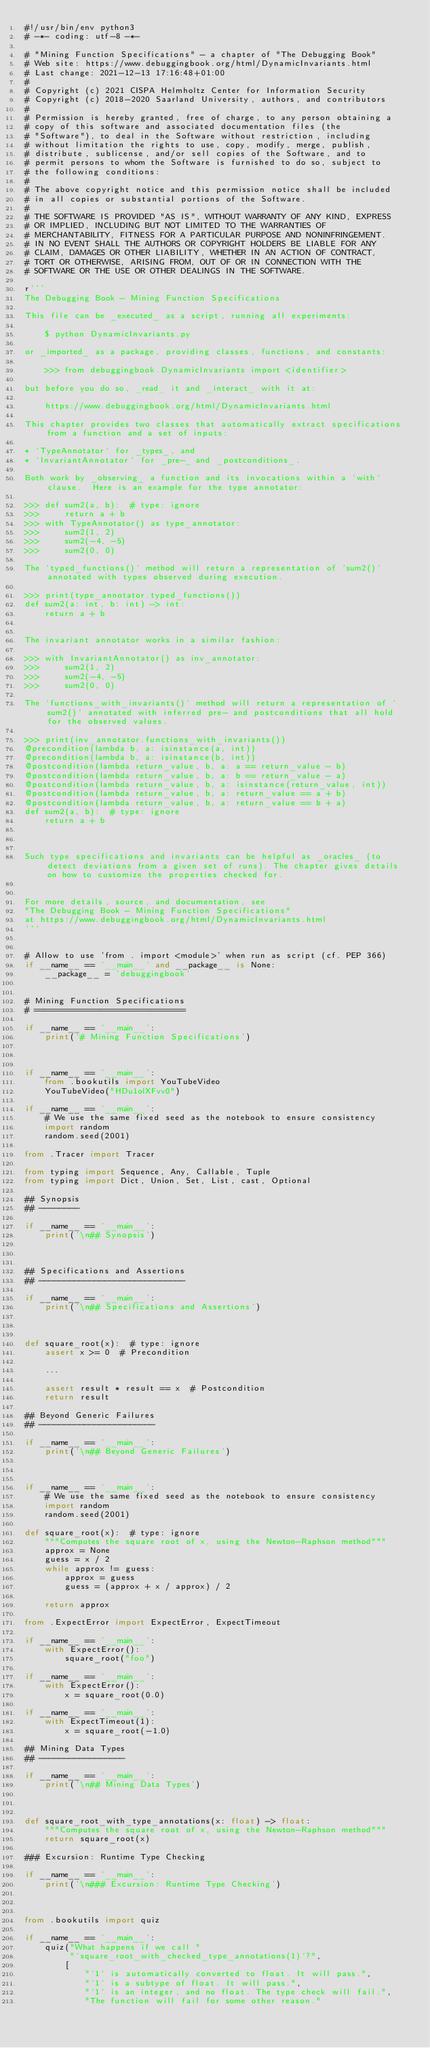Convert code to text. <code><loc_0><loc_0><loc_500><loc_500><_Python_>#!/usr/bin/env python3
# -*- coding: utf-8 -*-

# "Mining Function Specifications" - a chapter of "The Debugging Book"
# Web site: https://www.debuggingbook.org/html/DynamicInvariants.html
# Last change: 2021-12-13 17:16:48+01:00
#
# Copyright (c) 2021 CISPA Helmholtz Center for Information Security
# Copyright (c) 2018-2020 Saarland University, authors, and contributors
#
# Permission is hereby granted, free of charge, to any person obtaining a
# copy of this software and associated documentation files (the
# "Software"), to deal in the Software without restriction, including
# without limitation the rights to use, copy, modify, merge, publish,
# distribute, sublicense, and/or sell copies of the Software, and to
# permit persons to whom the Software is furnished to do so, subject to
# the following conditions:
#
# The above copyright notice and this permission notice shall be included
# in all copies or substantial portions of the Software.
#
# THE SOFTWARE IS PROVIDED "AS IS", WITHOUT WARRANTY OF ANY KIND, EXPRESS
# OR IMPLIED, INCLUDING BUT NOT LIMITED TO THE WARRANTIES OF
# MERCHANTABILITY, FITNESS FOR A PARTICULAR PURPOSE AND NONINFRINGEMENT.
# IN NO EVENT SHALL THE AUTHORS OR COPYRIGHT HOLDERS BE LIABLE FOR ANY
# CLAIM, DAMAGES OR OTHER LIABILITY, WHETHER IN AN ACTION OF CONTRACT,
# TORT OR OTHERWISE, ARISING FROM, OUT OF OR IN CONNECTION WITH THE
# SOFTWARE OR THE USE OR OTHER DEALINGS IN THE SOFTWARE.

r'''
The Debugging Book - Mining Function Specifications

This file can be _executed_ as a script, running all experiments:

    $ python DynamicInvariants.py

or _imported_ as a package, providing classes, functions, and constants:

    >>> from debuggingbook.DynamicInvariants import <identifier>
    
but before you do so, _read_ it and _interact_ with it at:

    https://www.debuggingbook.org/html/DynamicInvariants.html

This chapter provides two classes that automatically extract specifications from a function and a set of inputs:

* `TypeAnnotator` for _types_, and
* `InvariantAnnotator` for _pre-_ and _postconditions_.

Both work by _observing_ a function and its invocations within a `with` clause.  Here is an example for the type annotator:

>>> def sum2(a, b):  # type: ignore
>>>     return a + b
>>> with TypeAnnotator() as type_annotator:
>>>     sum2(1, 2)
>>>     sum2(-4, -5)
>>>     sum2(0, 0)

The `typed_functions()` method will return a representation of `sum2()` annotated with types observed during execution.

>>> print(type_annotator.typed_functions())
def sum2(a: int, b: int) -> int:
    return a + b


The invariant annotator works in a similar fashion:

>>> with InvariantAnnotator() as inv_annotator:
>>>     sum2(1, 2)
>>>     sum2(-4, -5)
>>>     sum2(0, 0)

The `functions_with_invariants()` method will return a representation of `sum2()` annotated with inferred pre- and postconditions that all hold for the observed values.

>>> print(inv_annotator.functions_with_invariants())
@precondition(lambda b, a: isinstance(a, int))
@precondition(lambda b, a: isinstance(b, int))
@postcondition(lambda return_value, b, a: a == return_value - b)
@postcondition(lambda return_value, b, a: b == return_value - a)
@postcondition(lambda return_value, b, a: isinstance(return_value, int))
@postcondition(lambda return_value, b, a: return_value == a + b)
@postcondition(lambda return_value, b, a: return_value == b + a)
def sum2(a, b):  # type: ignore
    return a + b



Such type specifications and invariants can be helpful as _oracles_ (to detect deviations from a given set of runs). The chapter gives details on how to customize the properties checked for.


For more details, source, and documentation, see
"The Debugging Book - Mining Function Specifications"
at https://www.debuggingbook.org/html/DynamicInvariants.html
'''


# Allow to use 'from . import <module>' when run as script (cf. PEP 366)
if __name__ == '__main__' and __package__ is None:
    __package__ = 'debuggingbook'


# Mining Function Specifications
# ==============================

if __name__ == '__main__':
    print('# Mining Function Specifications')



if __name__ == '__main__':
    from .bookutils import YouTubeVideo
    YouTubeVideo("HDu1olXFvv0")

if __name__ == '__main__':
    # We use the same fixed seed as the notebook to ensure consistency
    import random
    random.seed(2001)

from .Tracer import Tracer

from typing import Sequence, Any, Callable, Tuple
from typing import Dict, Union, Set, List, cast, Optional

## Synopsis
## --------

if __name__ == '__main__':
    print('\n## Synopsis')



## Specifications and Assertions
## -----------------------------

if __name__ == '__main__':
    print('\n## Specifications and Assertions')



def square_root(x):  # type: ignore
    assert x >= 0  # Precondition

    ...

    assert result * result == x  # Postcondition
    return result

## Beyond Generic Failures
## -----------------------

if __name__ == '__main__':
    print('\n## Beyond Generic Failures')



if __name__ == '__main__':
    # We use the same fixed seed as the notebook to ensure consistency
    import random
    random.seed(2001)

def square_root(x):  # type: ignore
    """Computes the square root of x, using the Newton-Raphson method"""
    approx = None
    guess = x / 2
    while approx != guess:
        approx = guess
        guess = (approx + x / approx) / 2

    return approx

from .ExpectError import ExpectError, ExpectTimeout

if __name__ == '__main__':
    with ExpectError():
        square_root("foo")

if __name__ == '__main__':
    with ExpectError():
        x = square_root(0.0)

if __name__ == '__main__':
    with ExpectTimeout(1):
        x = square_root(-1.0)

## Mining Data Types
## -----------------

if __name__ == '__main__':
    print('\n## Mining Data Types')



def square_root_with_type_annotations(x: float) -> float:
    """Computes the square root of x, using the Newton-Raphson method"""
    return square_root(x)

### Excursion: Runtime Type Checking

if __name__ == '__main__':
    print('\n### Excursion: Runtime Type Checking')



from .bookutils import quiz

if __name__ == '__main__':
    quiz("What happens if we call "
         "`square_root_with_checked_type_annotations(1)`?",
        [
            "`1` is automatically converted to float. It will pass.",
            "`1` is a subtype of float. It will pass.",
            "`1` is an integer, and no float. The type check will fail.",
            "The function will fail for some other reason."</code> 